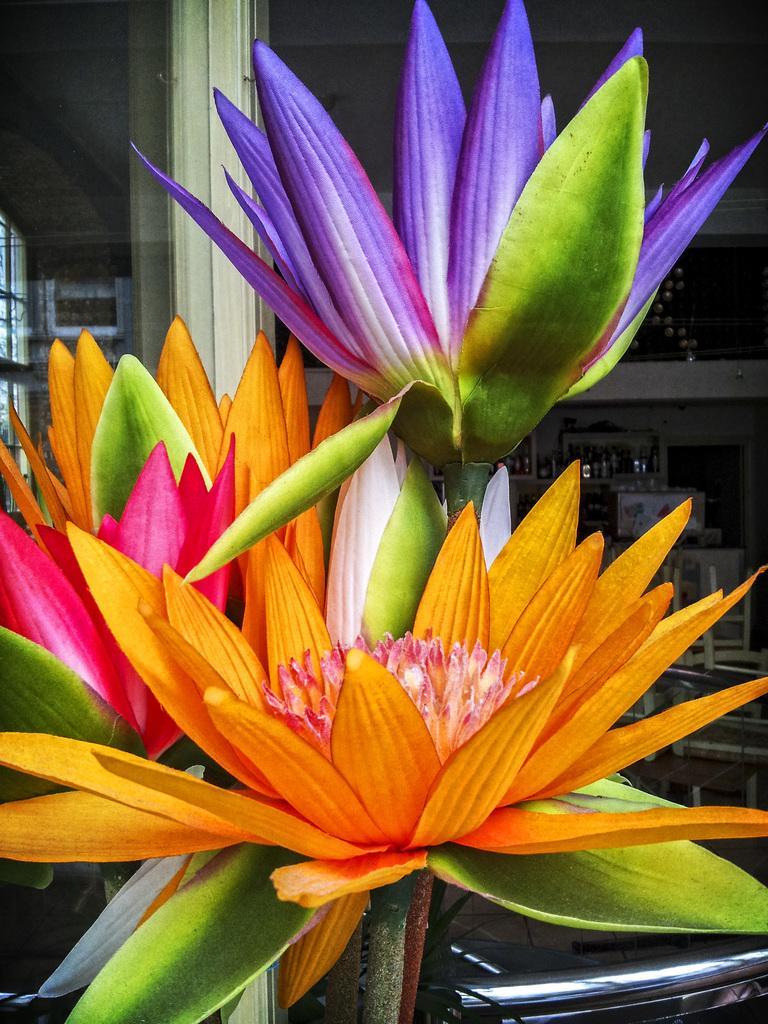Please provide a concise description of this image. In this image we can see a bunch of flowers. In the background, we can see a metal pole, some chairs, some objects placed on the surface and the window. 